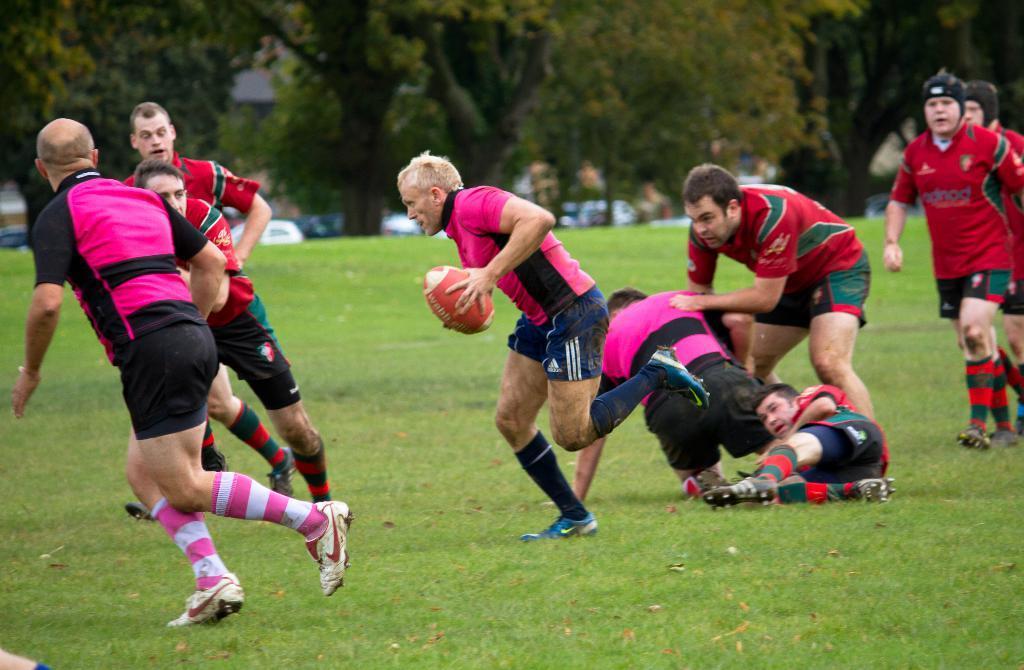Could you give a brief overview of what you see in this image? In this image, we can see people wearing sports dress and are playing a game and one of them is holding a ball. In the background, there are trees. At the bottom, there is ground. 